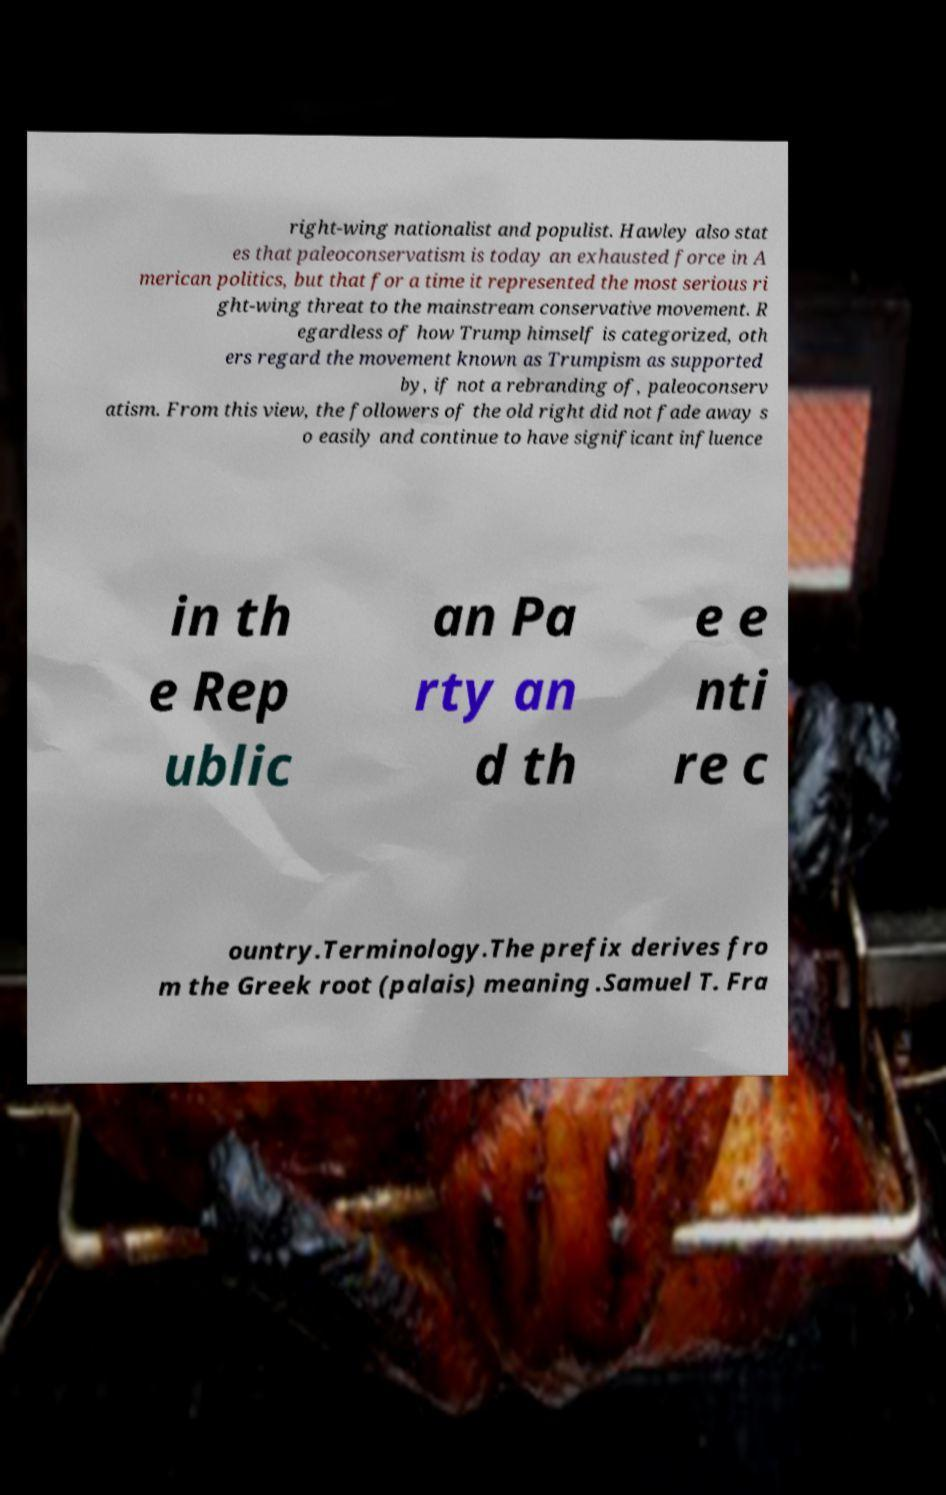For documentation purposes, I need the text within this image transcribed. Could you provide that? right-wing nationalist and populist. Hawley also stat es that paleoconservatism is today an exhausted force in A merican politics, but that for a time it represented the most serious ri ght-wing threat to the mainstream conservative movement. R egardless of how Trump himself is categorized, oth ers regard the movement known as Trumpism as supported by, if not a rebranding of, paleoconserv atism. From this view, the followers of the old right did not fade away s o easily and continue to have significant influence in th e Rep ublic an Pa rty an d th e e nti re c ountry.Terminology.The prefix derives fro m the Greek root (palais) meaning .Samuel T. Fra 